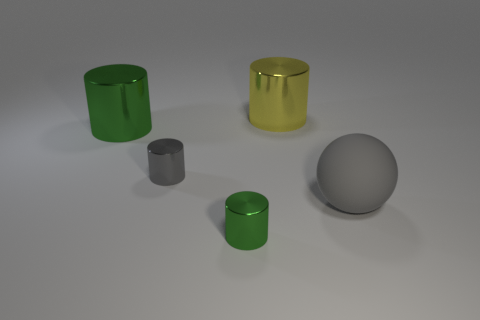There is a big metal object that is to the right of the small metallic object in front of the large gray matte thing; what color is it?
Ensure brevity in your answer.  Yellow. What is the material of the other tiny object that is the same shape as the small green metal thing?
Your answer should be compact. Metal. There is a large shiny object that is right of the large shiny object that is in front of the shiny cylinder that is behind the big green shiny cylinder; what is its color?
Provide a short and direct response. Yellow. What number of things are tiny blue cubes or small shiny objects?
Offer a terse response. 2. What number of green objects have the same shape as the large gray object?
Offer a very short reply. 0. Does the small gray object have the same material as the small object that is in front of the matte thing?
Offer a very short reply. Yes. There is a gray object that is the same material as the big green thing; what size is it?
Your answer should be compact. Small. How big is the gray object that is left of the large rubber sphere?
Offer a terse response. Small. How many green cylinders have the same size as the sphere?
Your answer should be compact. 1. What is the size of the shiny cylinder that is the same color as the big matte object?
Provide a succinct answer. Small. 